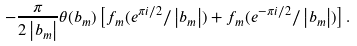Convert formula to latex. <formula><loc_0><loc_0><loc_500><loc_500>- \frac { \pi } { 2 \left | b _ { m } \right | } \theta ( b _ { m } ) \left [ f _ { m } ( e ^ { \pi i / 2 } / \left | b _ { m } \right | ) + f _ { m } ( e ^ { - \pi i / 2 } / \left | b _ { m } \right | ) \right ] .</formula> 